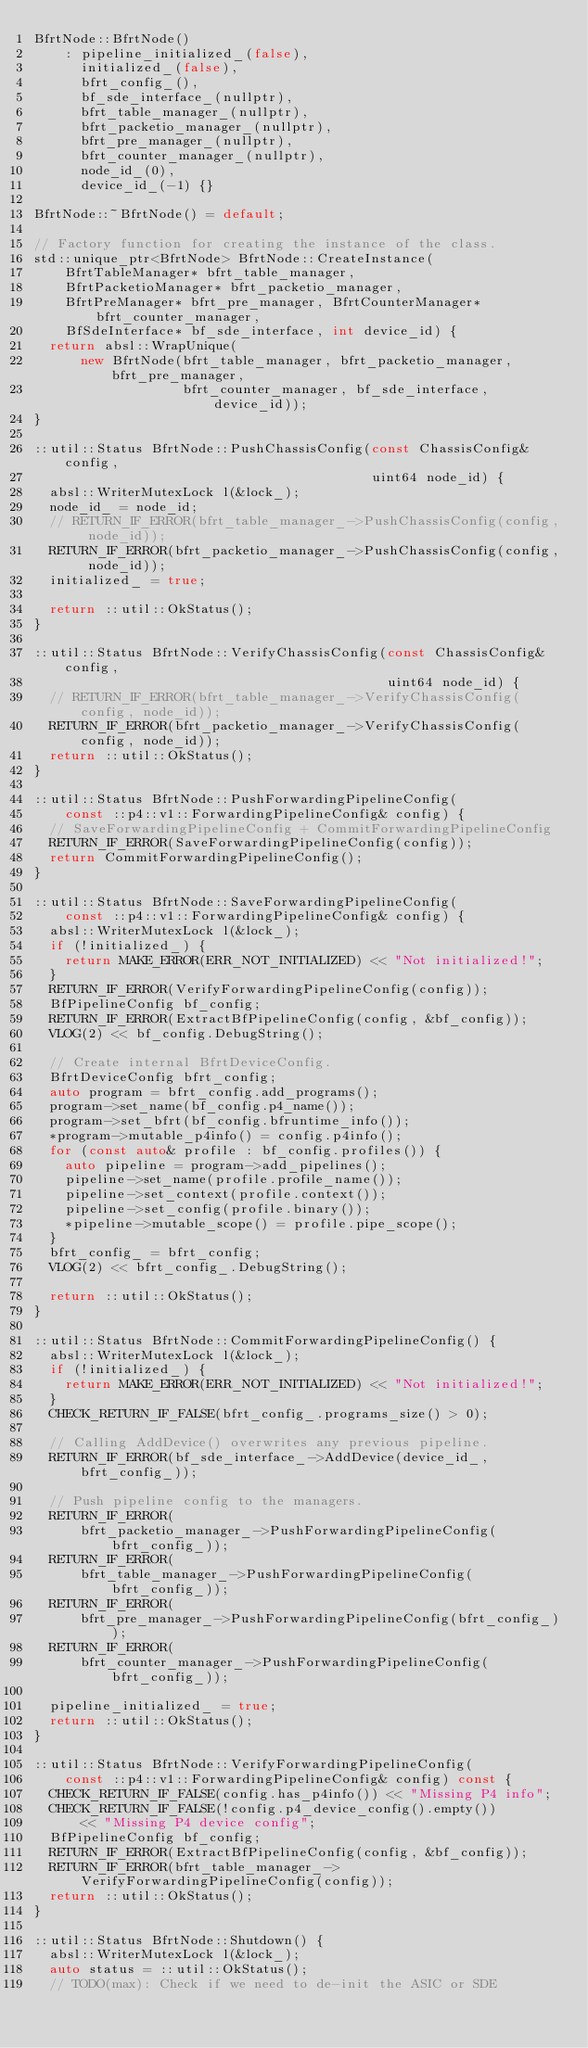Convert code to text. <code><loc_0><loc_0><loc_500><loc_500><_C++_>BfrtNode::BfrtNode()
    : pipeline_initialized_(false),
      initialized_(false),
      bfrt_config_(),
      bf_sde_interface_(nullptr),
      bfrt_table_manager_(nullptr),
      bfrt_packetio_manager_(nullptr),
      bfrt_pre_manager_(nullptr),
      bfrt_counter_manager_(nullptr),
      node_id_(0),
      device_id_(-1) {}

BfrtNode::~BfrtNode() = default;

// Factory function for creating the instance of the class.
std::unique_ptr<BfrtNode> BfrtNode::CreateInstance(
    BfrtTableManager* bfrt_table_manager,
    BfrtPacketioManager* bfrt_packetio_manager,
    BfrtPreManager* bfrt_pre_manager, BfrtCounterManager* bfrt_counter_manager,
    BfSdeInterface* bf_sde_interface, int device_id) {
  return absl::WrapUnique(
      new BfrtNode(bfrt_table_manager, bfrt_packetio_manager, bfrt_pre_manager,
                   bfrt_counter_manager, bf_sde_interface, device_id));
}

::util::Status BfrtNode::PushChassisConfig(const ChassisConfig& config,
                                           uint64 node_id) {
  absl::WriterMutexLock l(&lock_);
  node_id_ = node_id;
  // RETURN_IF_ERROR(bfrt_table_manager_->PushChassisConfig(config, node_id));
  RETURN_IF_ERROR(bfrt_packetio_manager_->PushChassisConfig(config, node_id));
  initialized_ = true;

  return ::util::OkStatus();
}

::util::Status BfrtNode::VerifyChassisConfig(const ChassisConfig& config,
                                             uint64 node_id) {
  // RETURN_IF_ERROR(bfrt_table_manager_->VerifyChassisConfig(config, node_id));
  RETURN_IF_ERROR(bfrt_packetio_manager_->VerifyChassisConfig(config, node_id));
  return ::util::OkStatus();
}

::util::Status BfrtNode::PushForwardingPipelineConfig(
    const ::p4::v1::ForwardingPipelineConfig& config) {
  // SaveForwardingPipelineConfig + CommitForwardingPipelineConfig
  RETURN_IF_ERROR(SaveForwardingPipelineConfig(config));
  return CommitForwardingPipelineConfig();
}

::util::Status BfrtNode::SaveForwardingPipelineConfig(
    const ::p4::v1::ForwardingPipelineConfig& config) {
  absl::WriterMutexLock l(&lock_);
  if (!initialized_) {
    return MAKE_ERROR(ERR_NOT_INITIALIZED) << "Not initialized!";
  }
  RETURN_IF_ERROR(VerifyForwardingPipelineConfig(config));
  BfPipelineConfig bf_config;
  RETURN_IF_ERROR(ExtractBfPipelineConfig(config, &bf_config));
  VLOG(2) << bf_config.DebugString();

  // Create internal BfrtDeviceConfig.
  BfrtDeviceConfig bfrt_config;
  auto program = bfrt_config.add_programs();
  program->set_name(bf_config.p4_name());
  program->set_bfrt(bf_config.bfruntime_info());
  *program->mutable_p4info() = config.p4info();
  for (const auto& profile : bf_config.profiles()) {
    auto pipeline = program->add_pipelines();
    pipeline->set_name(profile.profile_name());
    pipeline->set_context(profile.context());
    pipeline->set_config(profile.binary());
    *pipeline->mutable_scope() = profile.pipe_scope();
  }
  bfrt_config_ = bfrt_config;
  VLOG(2) << bfrt_config_.DebugString();

  return ::util::OkStatus();
}

::util::Status BfrtNode::CommitForwardingPipelineConfig() {
  absl::WriterMutexLock l(&lock_);
  if (!initialized_) {
    return MAKE_ERROR(ERR_NOT_INITIALIZED) << "Not initialized!";
  }
  CHECK_RETURN_IF_FALSE(bfrt_config_.programs_size() > 0);

  // Calling AddDevice() overwrites any previous pipeline.
  RETURN_IF_ERROR(bf_sde_interface_->AddDevice(device_id_, bfrt_config_));

  // Push pipeline config to the managers.
  RETURN_IF_ERROR(
      bfrt_packetio_manager_->PushForwardingPipelineConfig(bfrt_config_));
  RETURN_IF_ERROR(
      bfrt_table_manager_->PushForwardingPipelineConfig(bfrt_config_));
  RETURN_IF_ERROR(
      bfrt_pre_manager_->PushForwardingPipelineConfig(bfrt_config_));
  RETURN_IF_ERROR(
      bfrt_counter_manager_->PushForwardingPipelineConfig(bfrt_config_));

  pipeline_initialized_ = true;
  return ::util::OkStatus();
}

::util::Status BfrtNode::VerifyForwardingPipelineConfig(
    const ::p4::v1::ForwardingPipelineConfig& config) const {
  CHECK_RETURN_IF_FALSE(config.has_p4info()) << "Missing P4 info";
  CHECK_RETURN_IF_FALSE(!config.p4_device_config().empty())
      << "Missing P4 device config";
  BfPipelineConfig bf_config;
  RETURN_IF_ERROR(ExtractBfPipelineConfig(config, &bf_config));
  RETURN_IF_ERROR(bfrt_table_manager_->VerifyForwardingPipelineConfig(config));
  return ::util::OkStatus();
}

::util::Status BfrtNode::Shutdown() {
  absl::WriterMutexLock l(&lock_);
  auto status = ::util::OkStatus();
  // TODO(max): Check if we need to de-init the ASIC or SDE</code> 